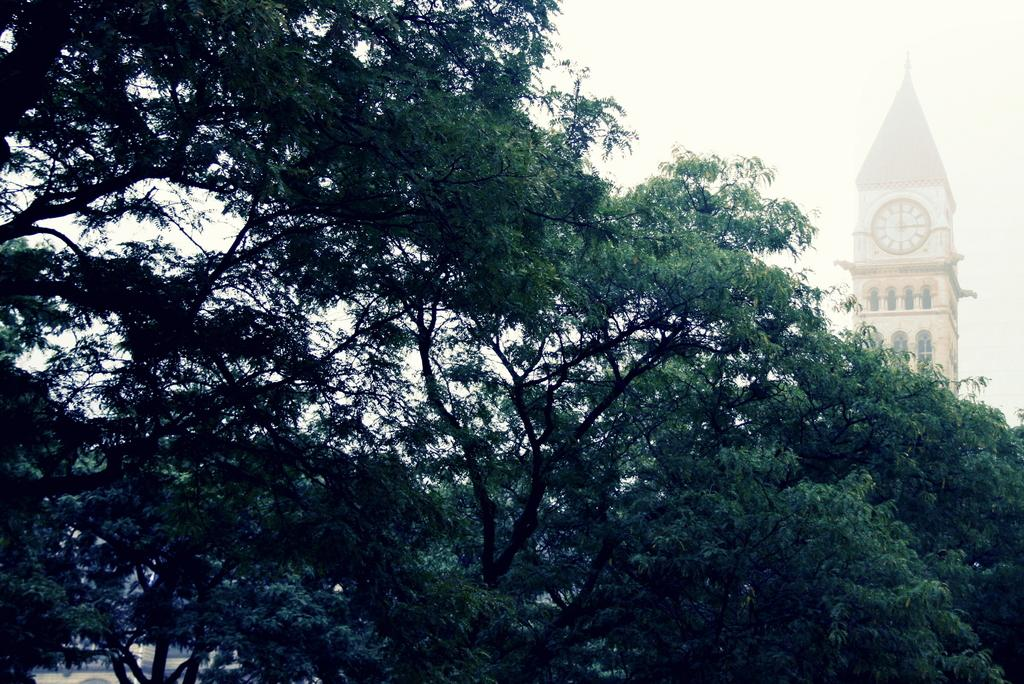What type of natural elements can be seen in the image? There are trees in the image. What type of structure is present in the image? There is a clock tower in the image. What can be seen in the background of the image? The sky is visible in the background of the image. What type of prison can be seen in the image? There is no prison present in the image; it features trees and a clock tower. What kind of music is being played in the image? There is no music or indication of any sound in the image. 